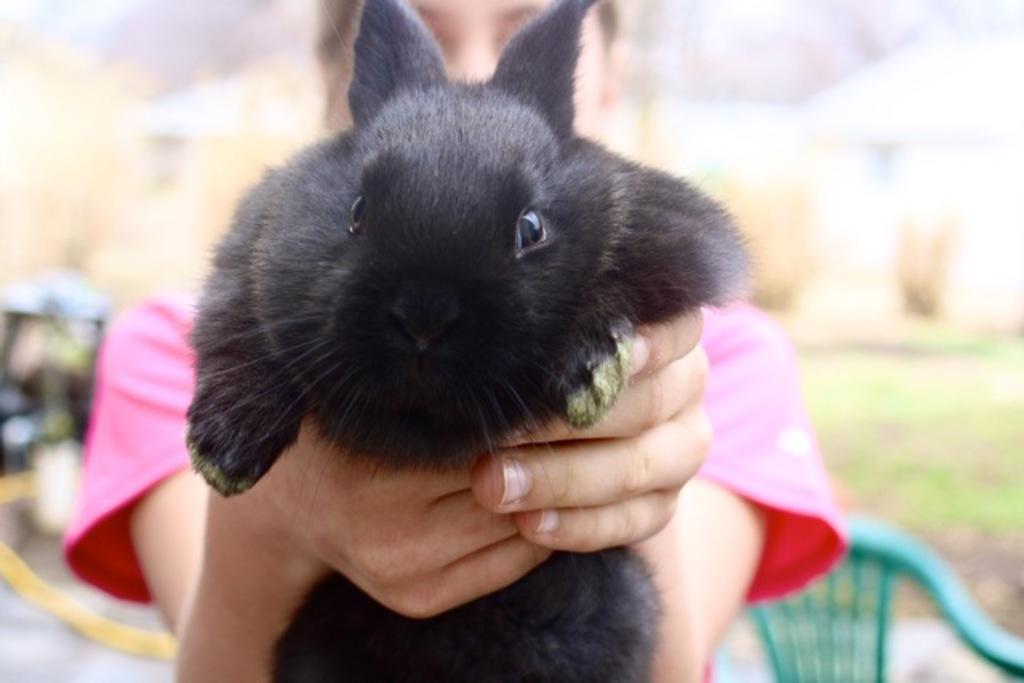What is the main subject of the image? There is a person in the image. What is the person holding in the image? The person is holding a black rabbit. Can you describe the background of the image? The background of the image is blurred. Where is the chair located in the image? There is a chair in the bottom right side of the image. What type of writing can be seen on the rabbit's ear in the image? There is no writing visible on the rabbit's ear in the image. What type of cabbage is being used as a prop in the image? There is no cabbage present in the image. 